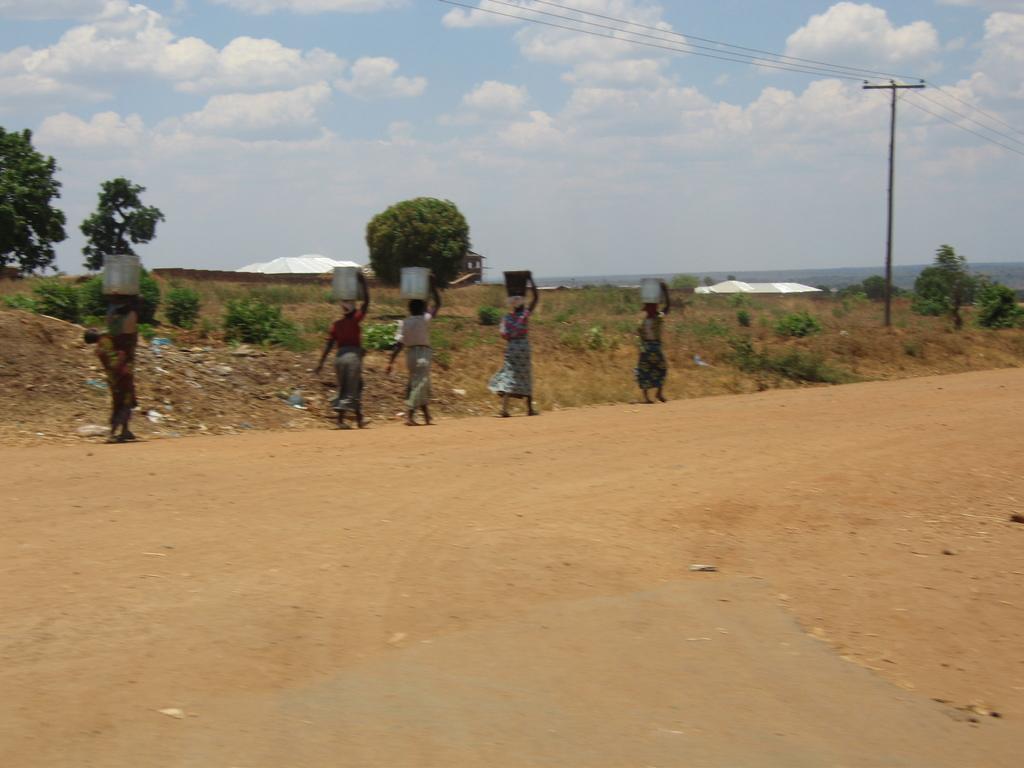How would you summarize this image in a sentence or two? In this image there are a few women are walking on the road carrying some utensils on their head, in the background of the image there are trees, electric poles with cables on top and tents, at the top of the image there are clouds in the sky. 